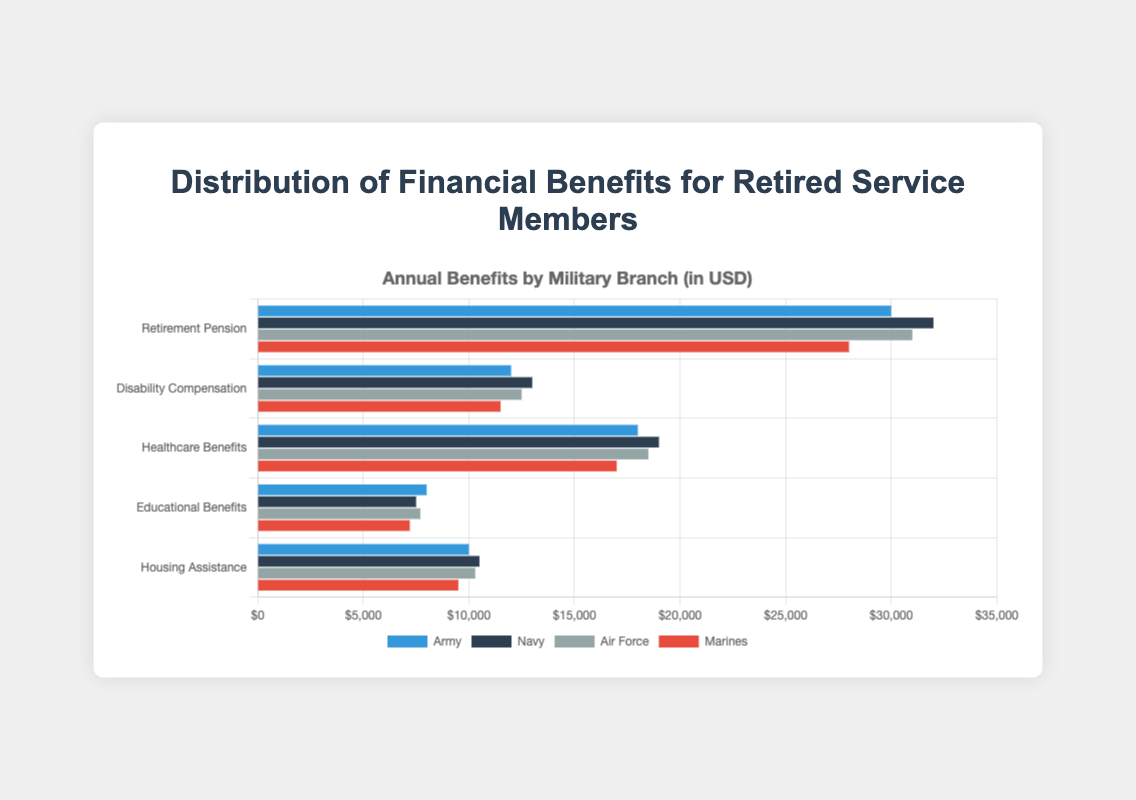Which branch receives the highest Retirement Pension? The Navy receives the highest Retirement Pension at $32,000, according to the bar lengths in the figure.
Answer: Navy Which branch receives the least Housing Assistance? The Marines receive the least Housing Assistance with $9,500, as shown by the shortest bar in that category.
Answer: Marines What is the total amount received in Educational Benefits across all branches? Adding the values: Army ($8,000) + Navy ($7,500) + Air Force ($7,700) + Marines ($7,200) = $30,400.
Answer: $30,400 Which category sees the greatest variation in benefits between the highest and the lowest branches? The Retirement Pension has the greatest variation: the Navy receives $32,000 and the Marines receive $28,000. The difference is $4,000.
Answer: Retirement Pension Compare the Healthcare Benefits received by the Army and the Air Force. The Army receives $18,000 while the Air Force receives $18,500.
Answer: Air Force receives $500 more What is the average Disability Compensation received by all branches? Adding the Disability Compensation for all branches: Army ($12,000) + Navy ($13,000) + Air Force ($12,500) + Marines ($11,500) = $ 49,000. The average is $49,000 / 4 = $12,250.
Answer: $12,250 How much more does the Air Force receive in Retirement Pension compared to the Marines? The Air Force receives $31,000 in Retirement Pension and the Marines $28,000. The difference is $31,000 - $28,000 = $3,000.
Answer: $3,000 Which branch receives the highest amount in Healthcare Benefits? The Navy receives the highest Healthcare Benefits of $19,000 as indicated by the bar lengths.
Answer: Navy Rank the branches in terms of Housing Assistance received from highest to lowest. The Navy ($10,500), Air Force ($10,300), Army ($10,000), Marines ($9,500).
Answer: Navy > Air Force > Army > Marines What is the sum of benefits received by the Army in all categories? Adding all categories for the Army: $30,000 (Retirement Pension) + $12,000 (Disability Compensation) + $18,000 (Healthcare Benefits) + $8,000 (Educational Benefits) + $10,000 (Housing Assistance) = $78,000.
Answer: $78,000 